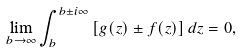Convert formula to latex. <formula><loc_0><loc_0><loc_500><loc_500>\lim _ { b \to \infty } \int _ { b } ^ { b \pm i \infty } { \left [ g ( z ) \pm f ( z ) \right ] d z } = 0 ,</formula> 